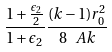<formula> <loc_0><loc_0><loc_500><loc_500>\frac { 1 + \frac { \epsilon _ { 2 } } { 2 } } { 1 + \epsilon _ { 2 } } \frac { ( k - 1 ) r _ { 0 } ^ { 2 } } { 8 \ A k }</formula> 